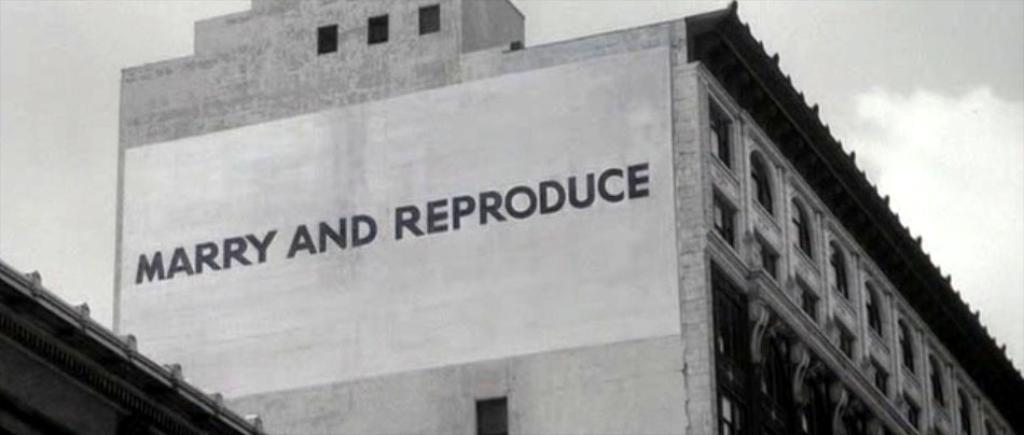How many buildings can be seen in the image? There are two buildings in the image. What is on one of the buildings? There is a board on one of the buildings. What can be seen in the background of the image? The sky is visible in the image. What type of crate can be seen floating on the waves in the image? There are no crates or waves present in the image; it features two buildings and a sky. 